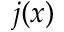Convert formula to latex. <formula><loc_0><loc_0><loc_500><loc_500>j ( x )</formula> 